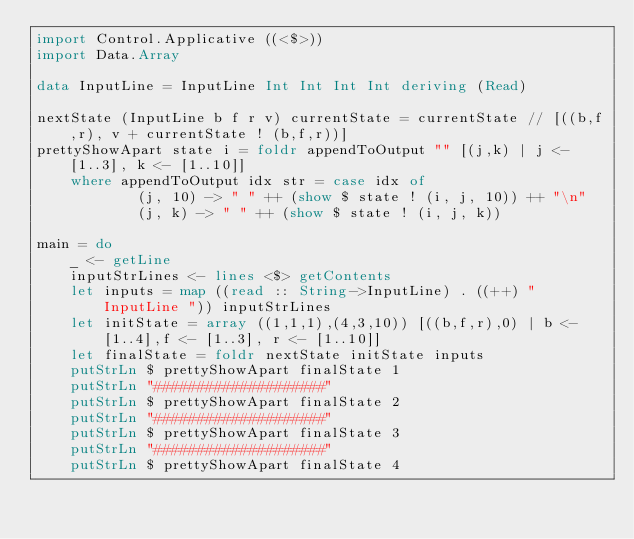<code> <loc_0><loc_0><loc_500><loc_500><_Haskell_>import Control.Applicative ((<$>))
import Data.Array

data InputLine = InputLine Int Int Int Int deriving (Read)

nextState (InputLine b f r v) currentState = currentState // [((b,f,r), v + currentState ! (b,f,r))]
prettyShowApart state i = foldr appendToOutput "" [(j,k) | j <- [1..3], k <- [1..10]]
    where appendToOutput idx str = case idx of
            (j, 10) -> " " ++ (show $ state ! (i, j, 10)) ++ "\n"
            (j, k) -> " " ++ (show $ state ! (i, j, k))

main = do
    _ <- getLine
    inputStrLines <- lines <$> getContents
    let inputs = map ((read :: String->InputLine) . ((++) "InputLine ")) inputStrLines
    let initState = array ((1,1,1),(4,3,10)) [((b,f,r),0) | b <- [1..4],f <- [1..3], r <- [1..10]]
    let finalState = foldr nextState initState inputs
    putStrLn $ prettyShowApart finalState 1
    putStrLn "####################"
    putStrLn $ prettyShowApart finalState 2
    putStrLn "####################"
    putStrLn $ prettyShowApart finalState 3
    putStrLn "####################"
    putStrLn $ prettyShowApart finalState 4</code> 